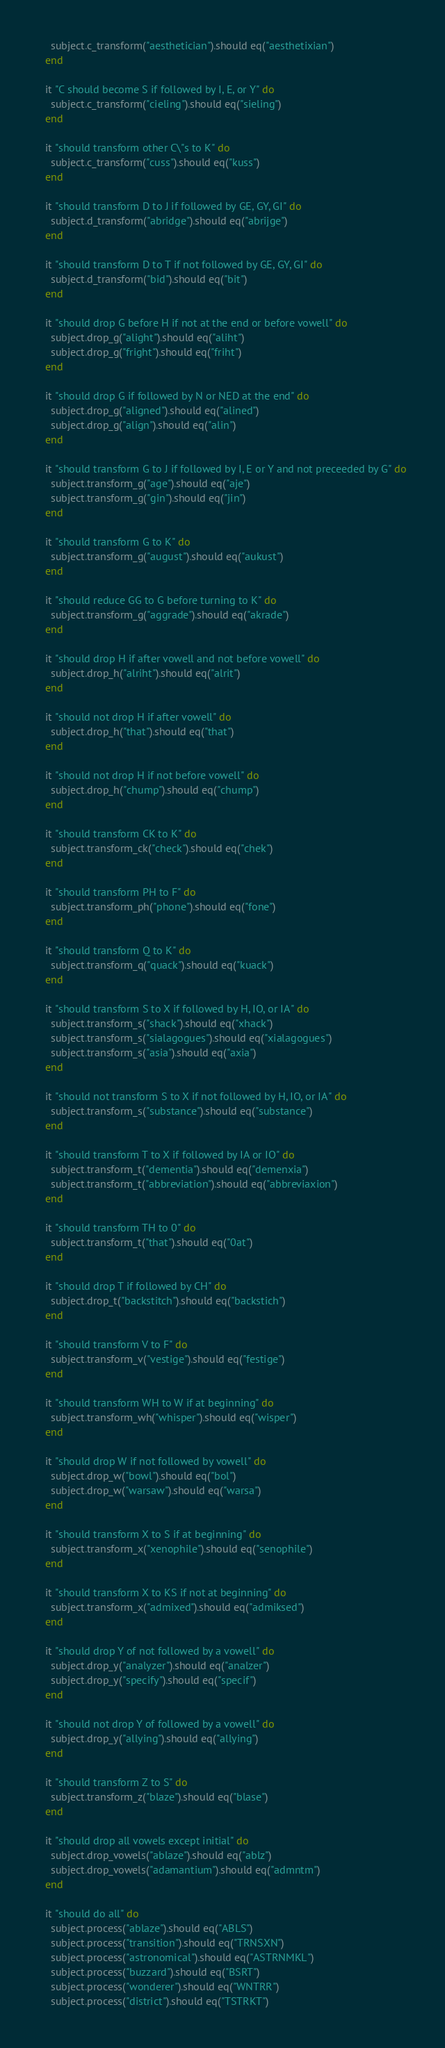<code> <loc_0><loc_0><loc_500><loc_500><_Crystal_>    subject.c_transform("aesthetician").should eq("aesthetixian")
  end

  it "C should become S if followed by I, E, or Y" do
    subject.c_transform("cieling").should eq("sieling")
  end

  it "should transform other C\"s to K" do
    subject.c_transform("cuss").should eq("kuss")
  end

  it "should transform D to J if followed by GE, GY, GI" do
    subject.d_transform("abridge").should eq("abrijge")
  end

  it "should transform D to T if not followed by GE, GY, GI" do
    subject.d_transform("bid").should eq("bit")
  end

  it "should drop G before H if not at the end or before vowell" do
    subject.drop_g("alight").should eq("aliht")
    subject.drop_g("fright").should eq("friht")
  end

  it "should drop G if followed by N or NED at the end" do
    subject.drop_g("aligned").should eq("alined")
    subject.drop_g("align").should eq("alin")
  end

  it "should transform G to J if followed by I, E or Y and not preceeded by G" do
    subject.transform_g("age").should eq("aje")
    subject.transform_g("gin").should eq("jin")
  end

  it "should transform G to K" do
    subject.transform_g("august").should eq("aukust")
  end

  it "should reduce GG to G before turning to K" do
    subject.transform_g("aggrade").should eq("akrade")
  end

  it "should drop H if after vowell and not before vowell" do
    subject.drop_h("alriht").should eq("alrit")
  end

  it "should not drop H if after vowell" do
    subject.drop_h("that").should eq("that")
  end

  it "should not drop H if not before vowell" do
    subject.drop_h("chump").should eq("chump")
  end

  it "should transform CK to K" do
    subject.transform_ck("check").should eq("chek")
  end

  it "should transform PH to F" do
    subject.transform_ph("phone").should eq("fone")
  end

  it "should transform Q to K" do
    subject.transform_q("quack").should eq("kuack")
  end

  it "should transform S to X if followed by H, IO, or IA" do
    subject.transform_s("shack").should eq("xhack")
    subject.transform_s("sialagogues").should eq("xialagogues")
    subject.transform_s("asia").should eq("axia")
  end

  it "should not transform S to X if not followed by H, IO, or IA" do
    subject.transform_s("substance").should eq("substance")
  end

  it "should transform T to X if followed by IA or IO" do
    subject.transform_t("dementia").should eq("demenxia")
    subject.transform_t("abbreviation").should eq("abbreviaxion")
  end

  it "should transform TH to 0" do
    subject.transform_t("that").should eq("0at")
  end

  it "should drop T if followed by CH" do
    subject.drop_t("backstitch").should eq("backstich")
  end

  it "should transform V to F" do
    subject.transform_v("vestige").should eq("festige")
  end

  it "should transform WH to W if at beginning" do
    subject.transform_wh("whisper").should eq("wisper")
  end

  it "should drop W if not followed by vowell" do
    subject.drop_w("bowl").should eq("bol")
    subject.drop_w("warsaw").should eq("warsa")
  end

  it "should transform X to S if at beginning" do
    subject.transform_x("xenophile").should eq("senophile")
  end

  it "should transform X to KS if not at beginning" do
    subject.transform_x("admixed").should eq("admiksed")
  end

  it "should drop Y of not followed by a vowell" do
    subject.drop_y("analyzer").should eq("analzer")
    subject.drop_y("specify").should eq("specif")
  end

  it "should not drop Y of followed by a vowell" do
    subject.drop_y("allying").should eq("allying")
  end

  it "should transform Z to S" do
    subject.transform_z("blaze").should eq("blase")
  end

  it "should drop all vowels except initial" do
    subject.drop_vowels("ablaze").should eq("ablz")
    subject.drop_vowels("adamantium").should eq("admntm")
  end

  it "should do all" do
    subject.process("ablaze").should eq("ABLS")
    subject.process("transition").should eq("TRNSXN")
    subject.process("astronomical").should eq("ASTRNMKL")
    subject.process("buzzard").should eq("BSRT")
    subject.process("wonderer").should eq("WNTRR")
    subject.process("district").should eq("TSTRKT")</code> 